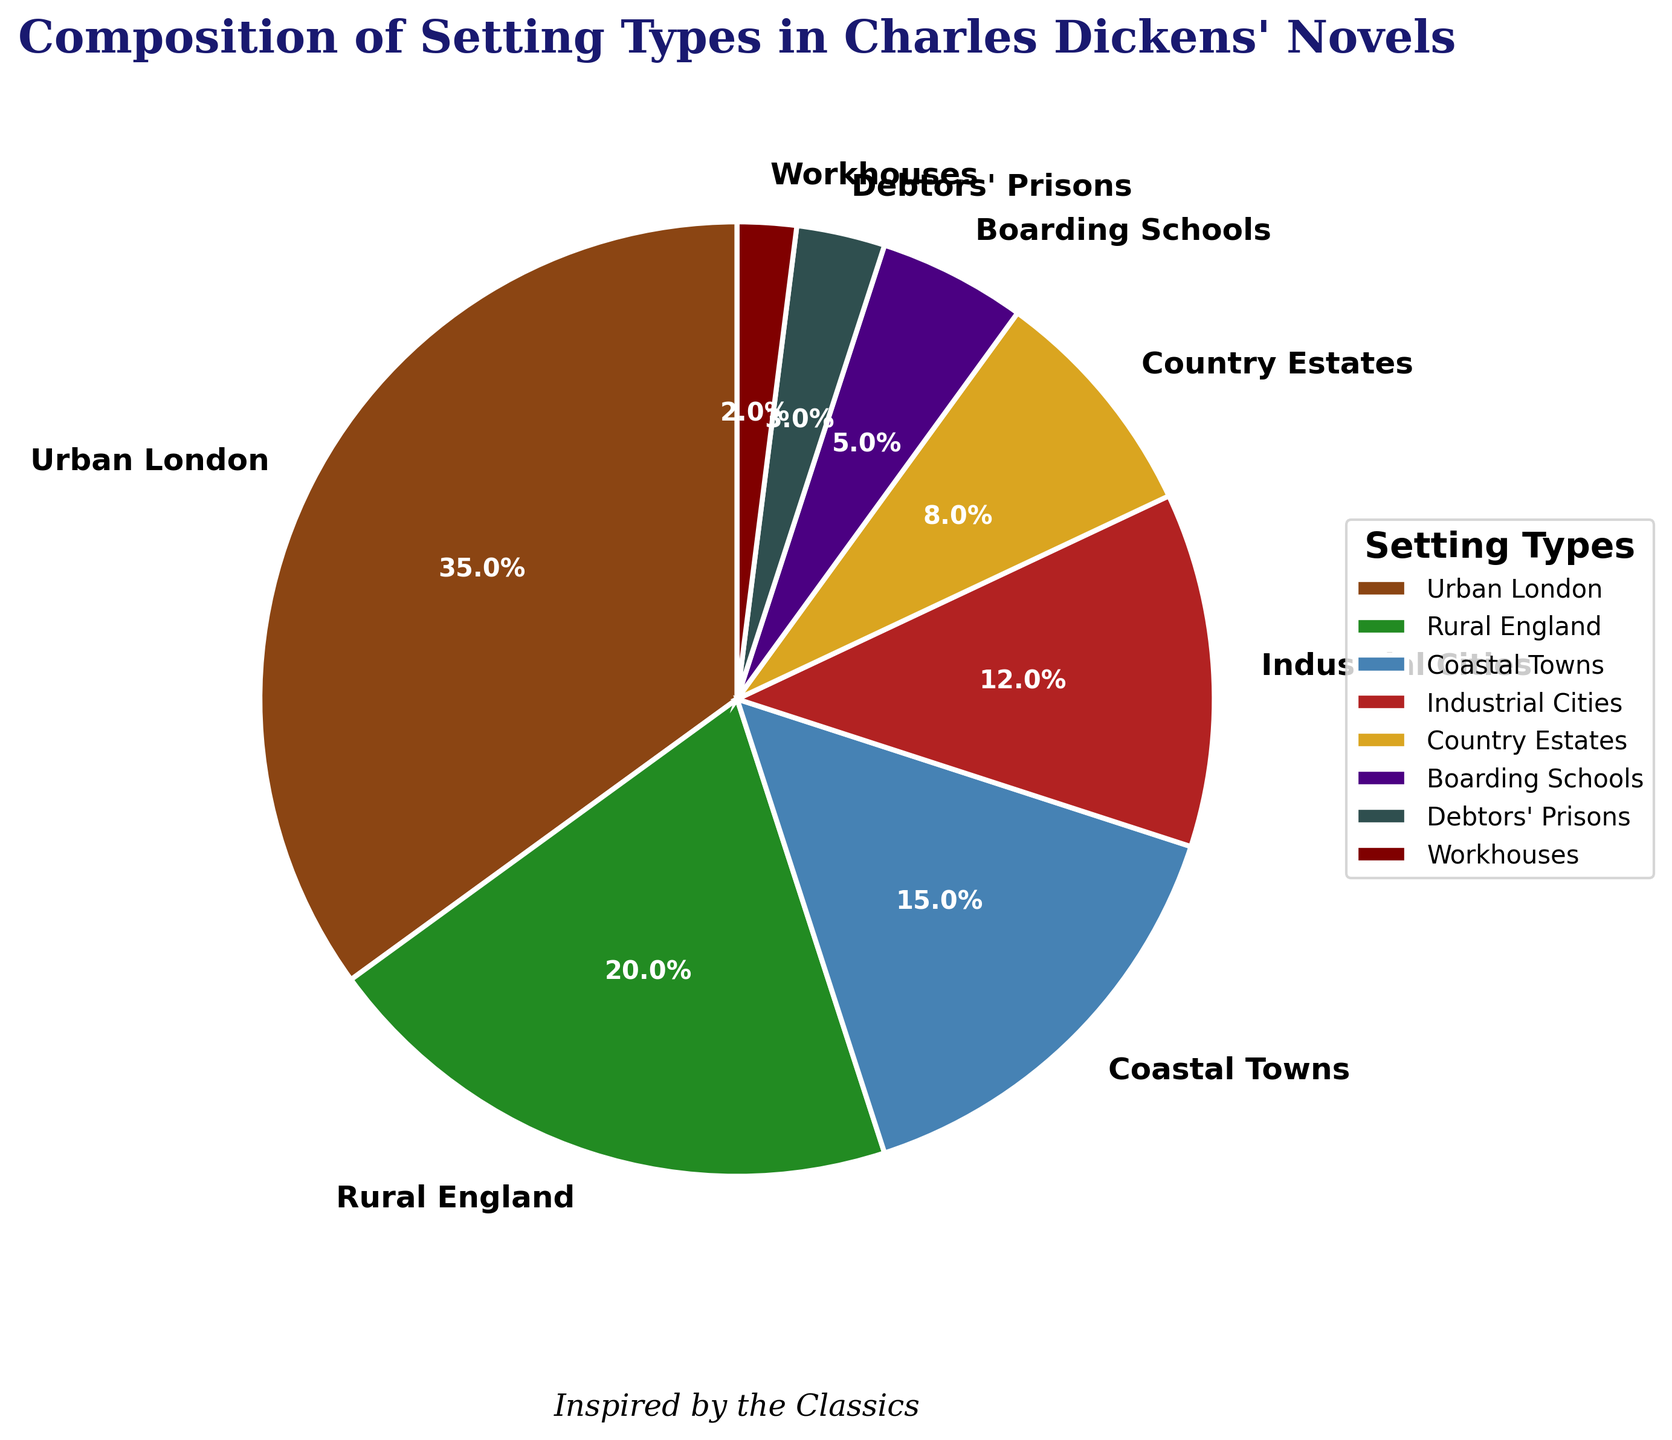What percentage of Charles Dickens' settings are urban London and industrial cities combined? To find the combined percentage, add the individual percentages of Urban London (35%) and Industrial Cities (12%). So, 35 + 12 = 47.
Answer: 47% How does the percentage of Coastal Towns compare to Country Estates? Compare the given percentages. Coastal Towns make up 15%, while Country Estates make up 8%. Since 15% is greater than 8%, Coastal Towns have a higher percentage.
Answer: Coastal Towns have a higher percentage Which setting type has the smallest percentage? From the given data, the smallest percentage is 2%, which corresponds to Workhouses.
Answer: Workhouses What is the ratio of rural settings (Rural England and Country Estates) to urban settings (Urban London and Industrial Cities)? Rural settings' combined percentage is 20% + 8% = 28%. Urban settings' combined percentage is 35% + 12% = 47%. Therefore, the ratio of rural to urban is 28:47. Simplify (divide both by their greatest common divisor, 1): 28:47.
Answer: 28:47 Which setting type occupies a middle ground in percentage terms, between Coastal Towns and Boarding Schools? Coastal Towns make up 15%, and Boarding Schools make up 5%. By observing the percentages, Industrial Cities sit in the middle with 12%.
Answer: Industrial Cities Are there more Country Estates or Debtors' Prisons in the settings of Dickens' novels? Country Estates have a percentage of 8%, while Debtors' Prisons have 3%. Comparing these, Country Estates have a higher percentage.
Answer: Country Estates If the percentages of Rural England and Coastal Towns were swapped, how would the new combined percentage of these settings compare to the original combined percentage? Original combined percentage of Rural England (20%) and Coastal Towns (15%) is 20 + 15 = 35%. Swapping them, the new combined percentage remains the same as each setting now retains the other's original value.
Answer: 35% What fraction of the settings is comprised of Boarding Schools and Debtors' Prisons combined? Add the percentages of Boarding Schools (5%) and Debtors' Prisons (3%), which equals 5 + 3 = 8%. In fraction form, this is 8/100, which simplifies to 2/25.
Answer: 2/25 Which setting types are represented by shades of green, and what are their respective percentages? Observing colors, Rural England (20%) and Industrial Cities (12%) are represented by shades of green.
Answer: Rural England (20%) and Industrial Cities (12%) If we grouped all settings into urban (Urban London, Industrial Cities, Workhouses) and non-urban categories, which category has the majority? Calculate percentages for urban: Urban London (35%), Industrial Cities (12%), Workhouses (2%) which adds up to 35 + 12 + 2 = 49%. Adding the percentages for non-urban settings, which include Rural England, Coastal Towns, Country Estates, Boarding Schools, and Debtors' Prisons: 20 + 15 + 8 + 5 + 3 = 51%. Non-urban thus holds the majority.
Answer: Non-urban 